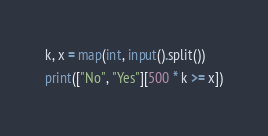Convert code to text. <code><loc_0><loc_0><loc_500><loc_500><_Python_>k, x = map(int, input().split())
print(["No", "Yes"][500 * k >= x])</code> 